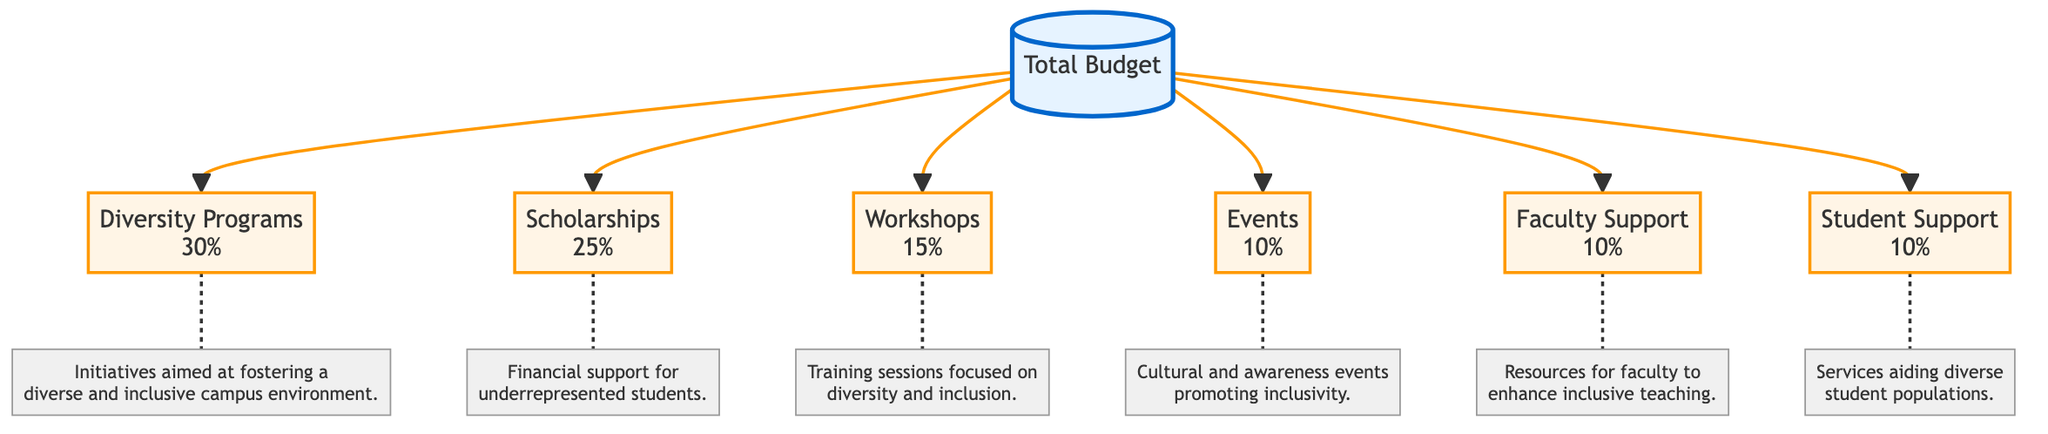What percentage of the total budget is allocated to diversity programs? The diagram specifically states that diversity programs receive 30% of the total budget. This is directly indicated next to the "Diversity Programs" node.
Answer: 30% What are the total percentages allocated to faculty support and student support combined? The diagram shows that both faculty support and student support are allocated 10% each. Therefore, adding these two percentages together gives us 10% + 10% = 20%.
Answer: 20% How many categories are shown in the budget breakdown? The diagram includes six distinct categories for budget allocation: diversity programs, scholarships, workshops, events, faculty support, and student support. Counting these gives a total of six categories.
Answer: 6 What does the note for scholarships indicate? The scholarship node is connected to a note that states "Financial support for underrepresented students." This provides context for the purpose of the allocation.
Answer: Financial support for underrepresented students Which allocation category has the smallest percentage? Reviewing all the categories listed in the diagram, events and faculty support both have the smallest allocation at 10%. However, since events are listed first, we refer to that as the answer.
Answer: Events How does the percentage of workshops compare to scholarships? The diagram shows that workshops are allocated 15%, while scholarships are allocated 25%. Comparing these two percentages indicates that scholarships receive a larger allocation.
Answer: Scholarships receive a larger allocation What type of initiatives does the programs category focus on? The note associated with the programs category reads: "Initiatives aimed at fostering a diverse and inclusive campus environment." This describes the focus of the programs.
Answer: Fostering a diverse and inclusive campus environment 